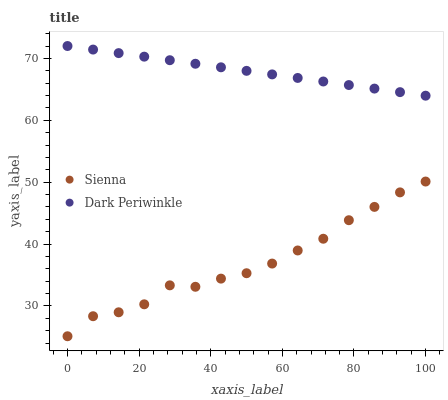Does Sienna have the minimum area under the curve?
Answer yes or no. Yes. Does Dark Periwinkle have the maximum area under the curve?
Answer yes or no. Yes. Does Dark Periwinkle have the minimum area under the curve?
Answer yes or no. No. Is Dark Periwinkle the smoothest?
Answer yes or no. Yes. Is Sienna the roughest?
Answer yes or no. Yes. Is Dark Periwinkle the roughest?
Answer yes or no. No. Does Sienna have the lowest value?
Answer yes or no. Yes. Does Dark Periwinkle have the lowest value?
Answer yes or no. No. Does Dark Periwinkle have the highest value?
Answer yes or no. Yes. Is Sienna less than Dark Periwinkle?
Answer yes or no. Yes. Is Dark Periwinkle greater than Sienna?
Answer yes or no. Yes. Does Sienna intersect Dark Periwinkle?
Answer yes or no. No. 